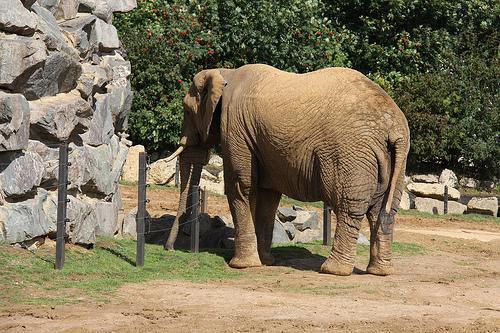How many elephants?
Give a very brief answer. 1. How many wires on fence?
Give a very brief answer. 6. How many tusks visible?
Give a very brief answer. 1. 